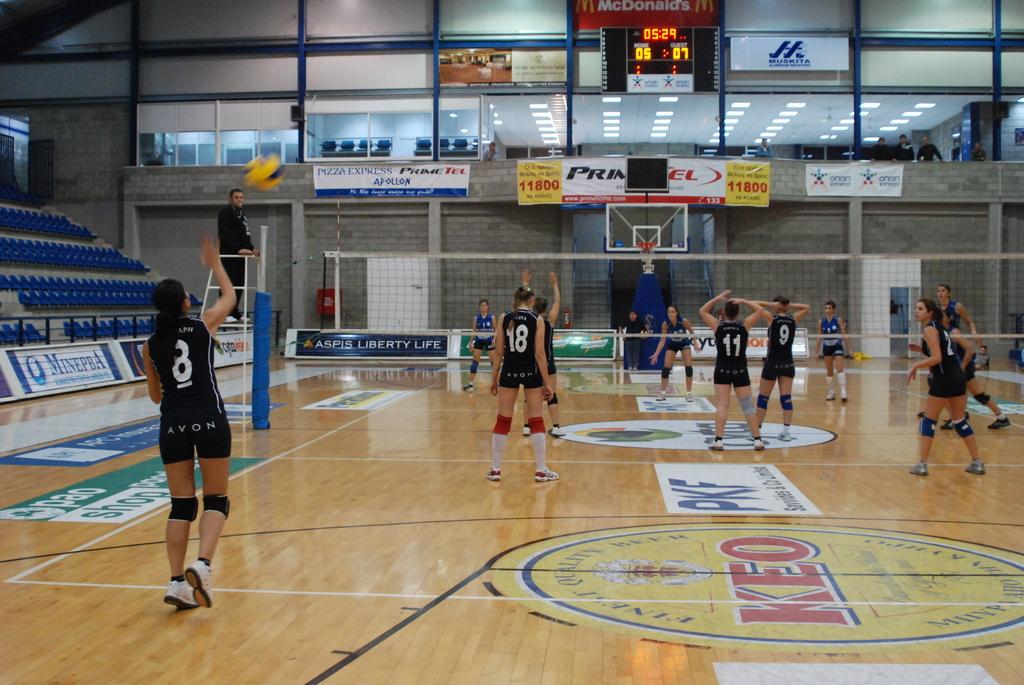What is the number of the closest jersey?
Provide a succinct answer. 8. What fast food restaurant in advertised above the score board?
Provide a succinct answer. Mcdonalds. 